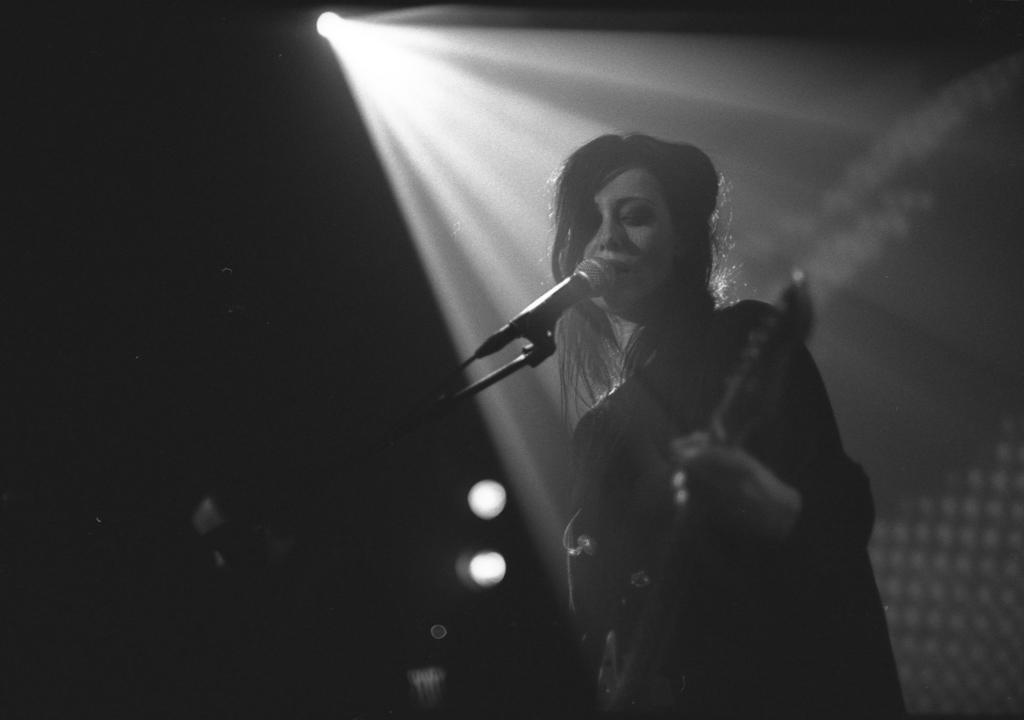Please provide a concise description of this image. This looks like a black and white image. I can see the woman standing and playing a musical instrument. I think she is singing a song. This is the mike with the mike stand. At the top of the image, I can see a light ray. 